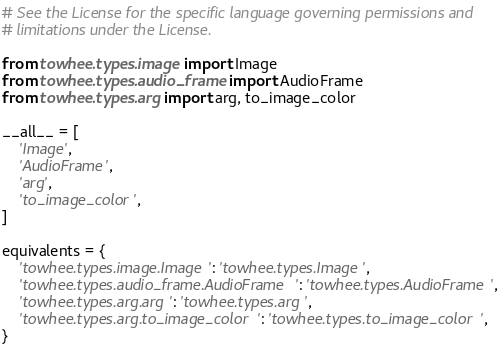Convert code to text. <code><loc_0><loc_0><loc_500><loc_500><_Python_># See the License for the specific language governing permissions and
# limitations under the License.

from towhee.types.image import Image
from towhee.types.audio_frame import AudioFrame
from towhee.types.arg import arg, to_image_color

__all__ = [
    'Image',
    'AudioFrame',
    'arg',
    'to_image_color',
]

equivalents = {
    'towhee.types.image.Image': 'towhee.types.Image',
    'towhee.types.audio_frame.AudioFrame': 'towhee.types.AudioFrame',
    'towhee.types.arg.arg': 'towhee.types.arg',
    'towhee.types.arg.to_image_color': 'towhee.types.to_image_color',
}
</code> 